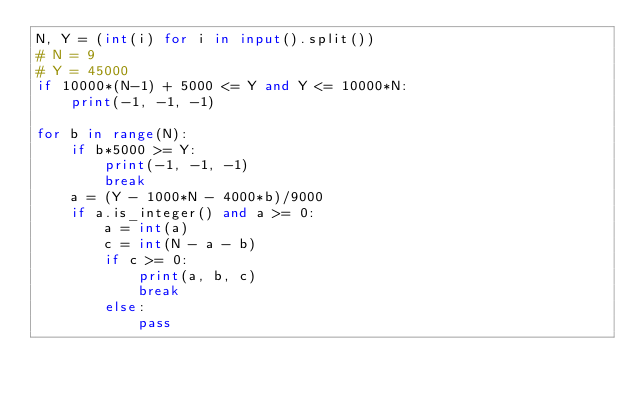<code> <loc_0><loc_0><loc_500><loc_500><_Python_>N, Y = (int(i) for i in input().split())
# N = 9
# Y = 45000
if 10000*(N-1) + 5000 <= Y and Y <= 10000*N:
    print(-1, -1, -1)

for b in range(N):
    if b*5000 >= Y:
        print(-1, -1, -1)
        break
    a = (Y - 1000*N - 4000*b)/9000
    if a.is_integer() and a >= 0:
        a = int(a)
        c = int(N - a - b)
        if c >= 0:
            print(a, b, c)
            break
        else:
            pass
</code> 